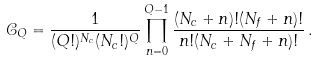<formula> <loc_0><loc_0><loc_500><loc_500>\mathcal { C } _ { Q } = \frac { 1 } { ( Q ! ) ^ { N _ { c } } ( N _ { c } ! ) ^ { Q } } \prod _ { n = 0 } ^ { Q - 1 } \frac { ( N _ { c } + n ) ! ( N _ { f } + n ) ! } { n ! ( N _ { c } + N _ { f } + n ) ! } \, .</formula> 